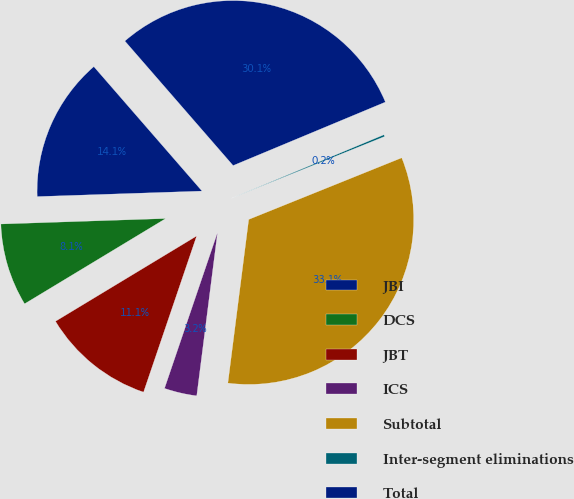<chart> <loc_0><loc_0><loc_500><loc_500><pie_chart><fcel>JBI<fcel>DCS<fcel>JBT<fcel>ICS<fcel>Subtotal<fcel>Inter-segment eliminations<fcel>Total<nl><fcel>14.14%<fcel>8.12%<fcel>11.13%<fcel>3.2%<fcel>33.11%<fcel>0.19%<fcel>30.1%<nl></chart> 